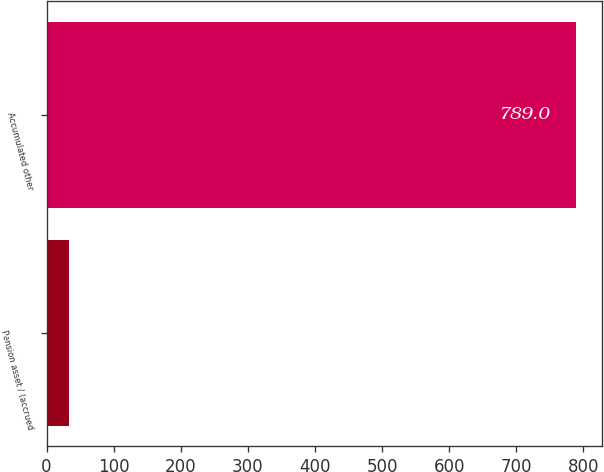Convert chart to OTSL. <chart><loc_0><loc_0><loc_500><loc_500><bar_chart><fcel>Pension asset / (accrued<fcel>Accumulated other<nl><fcel>33<fcel>789<nl></chart> 